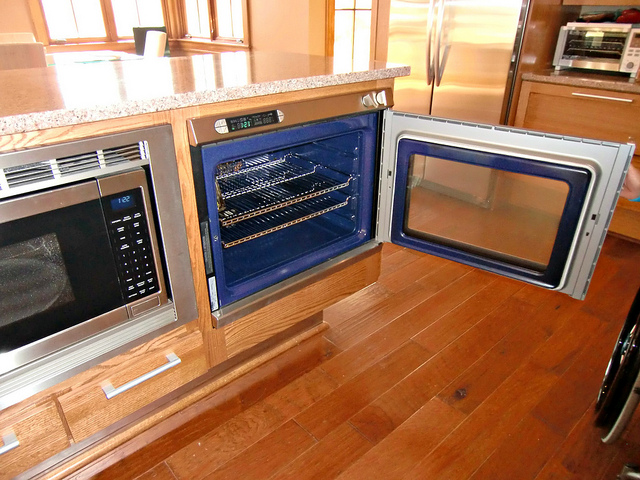<image>What is the time on the microwave? I am not sure about the time on the microwave. It could be '1:42', '1:22', '1:02' or '11'. What is the time on the microwave? I don't know what the time is on the microwave. It can be seen as '1:42' or '1:22'. 